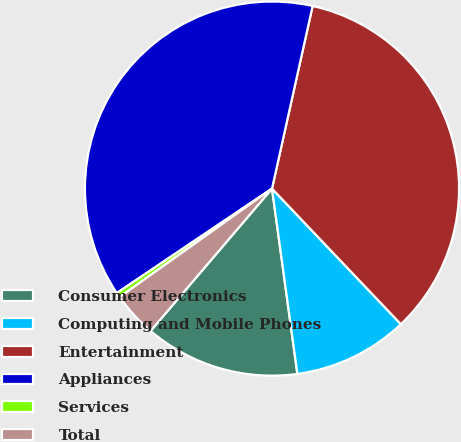<chart> <loc_0><loc_0><loc_500><loc_500><pie_chart><fcel>Consumer Electronics<fcel>Computing and Mobile Phones<fcel>Entertainment<fcel>Appliances<fcel>Services<fcel>Total<nl><fcel>13.41%<fcel>9.93%<fcel>34.42%<fcel>37.91%<fcel>0.42%<fcel>3.91%<nl></chart> 